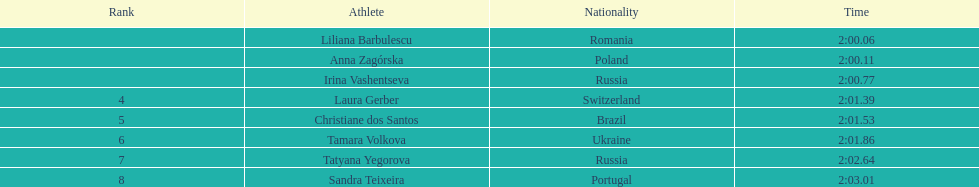What was the prior time for the 7th runner? 2:02.64. 